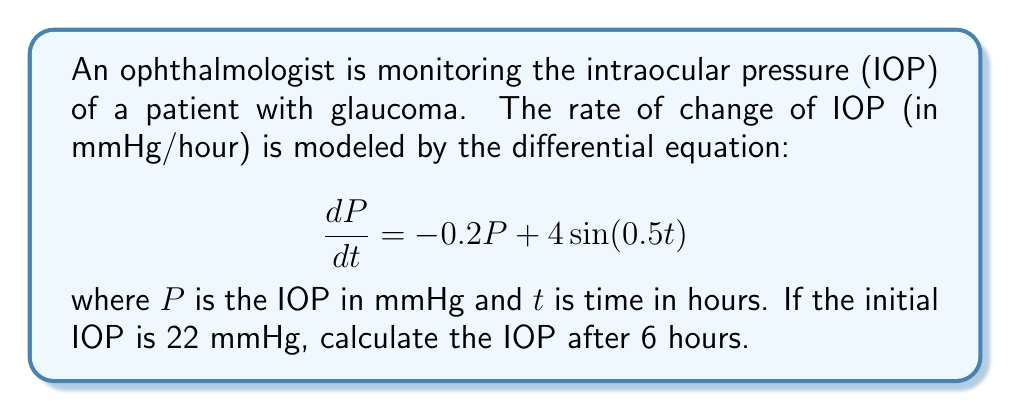What is the answer to this math problem? To solve this problem, we need to use the method of integrating factors:

1) The differential equation is in the form:
   $$\frac{dP}{dt} + 0.2P = 4\sin(0.5t)$$

2) The integrating factor is $\mu(t) = e^{\int 0.2 dt} = e^{0.2t}$

3) Multiplying both sides by $\mu(t)$:
   $$e^{0.2t}\frac{dP}{dt} + 0.2Pe^{0.2t} = 4e^{0.2t}\sin(0.5t)$$

4) The left side is now the derivative of $Pe^{0.2t}$:
   $$\frac{d}{dt}(Pe^{0.2t}) = 4e^{0.2t}\sin(0.5t)$$

5) Integrating both sides:
   $$Pe^{0.2t} = \int 4e^{0.2t}\sin(0.5t)dt$$

6) Using integration by parts:
   $$Pe^{0.2t} = 4\left(\frac{e^{0.2t}(0.2\sin(0.5t) - 0.5\cos(0.5t))}{0.04 + 0.25}\right) + C$$

7) Simplifying:
   $$P = \frac{4(0.2\sin(0.5t) - 0.5\cos(0.5t))}{0.29} + Ce^{-0.2t}$$

8) Using the initial condition $P(0) = 22$:
   $$22 = \frac{4(-0.5)}{0.29} + C$$
   $$C = 22 + \frac{2}{0.29} \approx 28.90$$

9) The final solution is:
   $$P(t) = \frac{4(0.2\sin(0.5t) - 0.5\cos(0.5t))}{0.29} + 28.90e^{-0.2t}$$

10) Evaluating at $t = 6$:
    $$P(6) = \frac{4(0.2\sin(3) - 0.5\cos(3))}{0.29} + 28.90e^{-1.2} \approx 18.76$$
Answer: 18.76 mmHg 